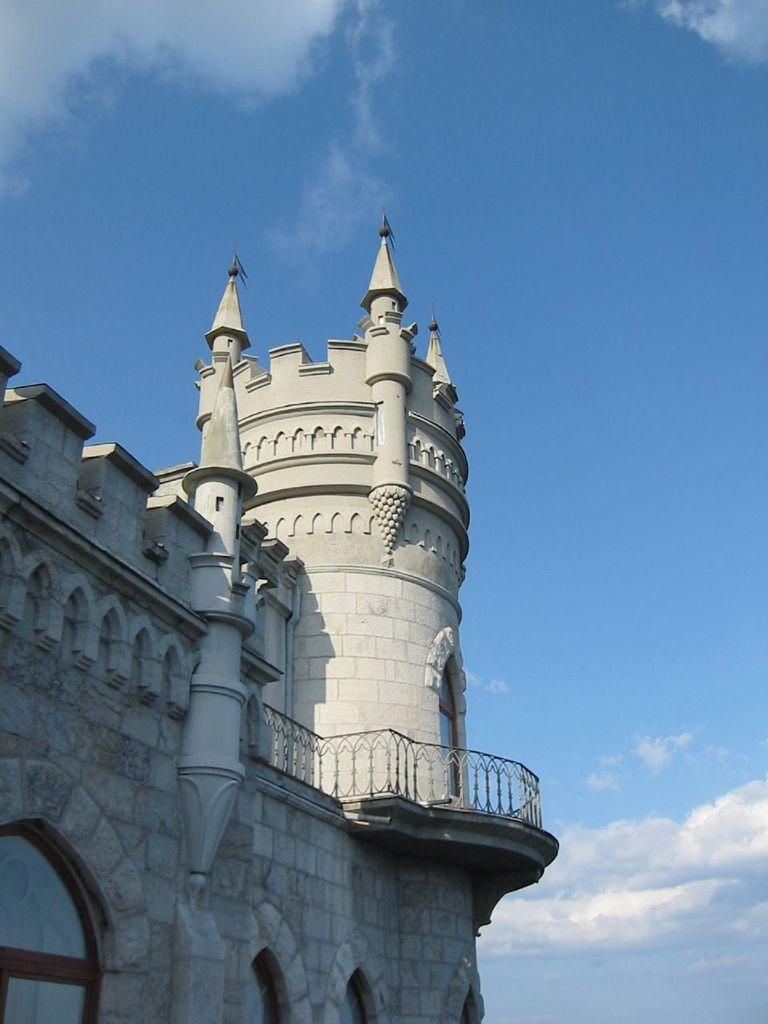What type of structure is in the picture? There is a building in the picture. What feature can be seen on the building? The building has windows. What is located near the building? There is a fence in the picture. What can be seen in the background of the picture? The sky is visible in the background of the picture. What is the condition of the sky in the picture? Clouds are present in the sky. What type of yak can be seen grazing near the building in the picture? There is no yak present in the picture; it features a building with windows, a fence, and a cloudy sky. 